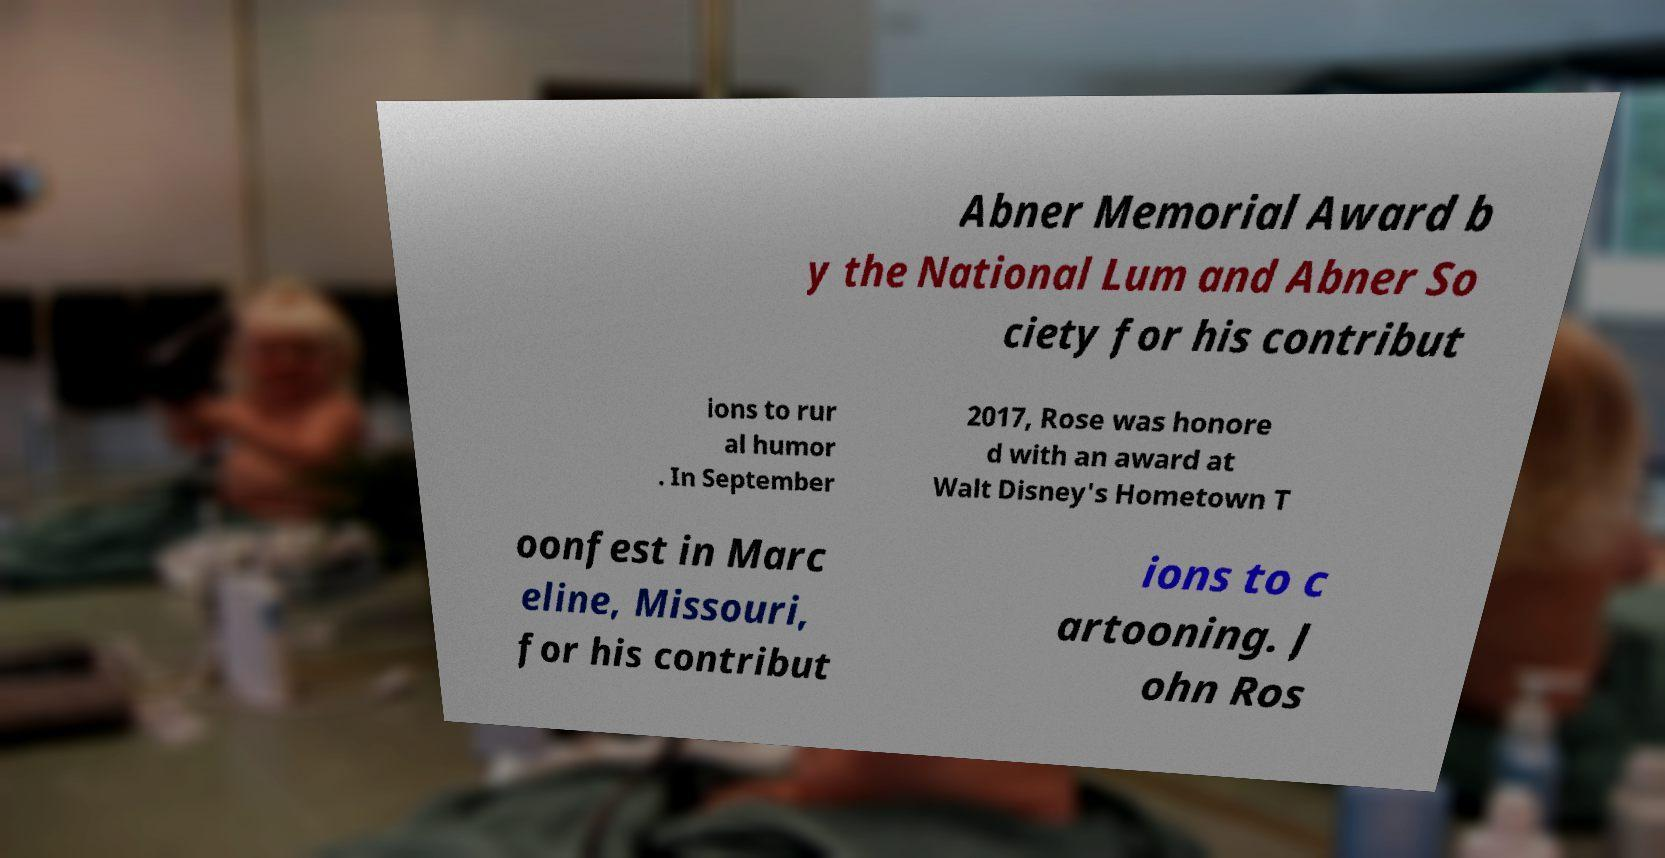Please identify and transcribe the text found in this image. Abner Memorial Award b y the National Lum and Abner So ciety for his contribut ions to rur al humor . In September 2017, Rose was honore d with an award at Walt Disney's Hometown T oonfest in Marc eline, Missouri, for his contribut ions to c artooning. J ohn Ros 